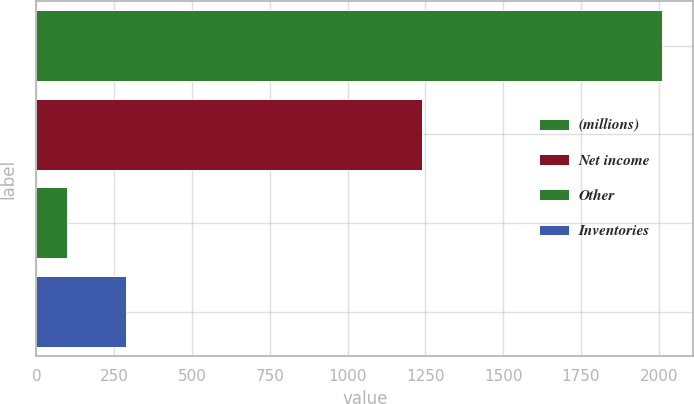Convert chart. <chart><loc_0><loc_0><loc_500><loc_500><bar_chart><fcel>(millions)<fcel>Net income<fcel>Other<fcel>Inventories<nl><fcel>2010<fcel>1240<fcel>97<fcel>288.3<nl></chart> 